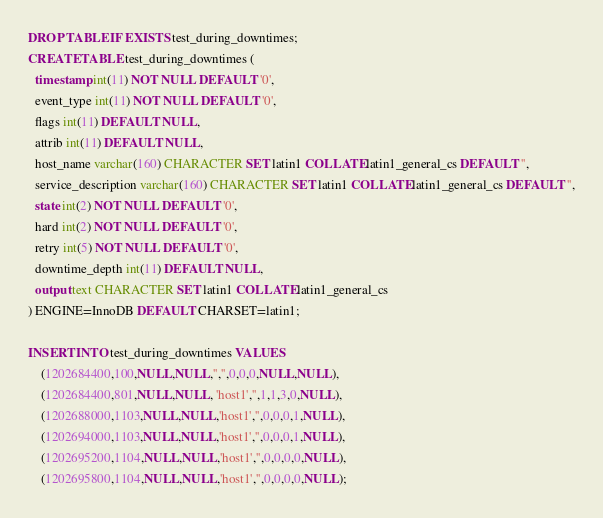Convert code to text. <code><loc_0><loc_0><loc_500><loc_500><_SQL_>DROP TABLE IF EXISTS test_during_downtimes;
CREATE TABLE test_during_downtimes (
  timestamp int(11) NOT NULL DEFAULT '0',
  event_type int(11) NOT NULL DEFAULT '0',
  flags int(11) DEFAULT NULL,
  attrib int(11) DEFAULT NULL,
  host_name varchar(160) CHARACTER SET latin1 COLLATE latin1_general_cs DEFAULT '',
  service_description varchar(160) CHARACTER SET latin1 COLLATE latin1_general_cs DEFAULT '',
  state int(2) NOT NULL DEFAULT '0',
  hard int(2) NOT NULL DEFAULT '0',
  retry int(5) NOT NULL DEFAULT '0',
  downtime_depth int(11) DEFAULT NULL,
  output text CHARACTER SET latin1 COLLATE latin1_general_cs
) ENGINE=InnoDB DEFAULT CHARSET=latin1;

INSERT INTO test_during_downtimes VALUES
	(1202684400,100,NULL,NULL,'','',0,0,0,NULL,NULL),
	(1202684400,801,NULL,NULL, 'host1','',1,1,3,0,NULL),
	(1202688000,1103,NULL,NULL,'host1','',0,0,0,1,NULL),
	(1202694000,1103,NULL,NULL,'host1','',0,0,0,1,NULL),
	(1202695200,1104,NULL,NULL,'host1','',0,0,0,0,NULL),
	(1202695800,1104,NULL,NULL,'host1','',0,0,0,0,NULL);
</code> 